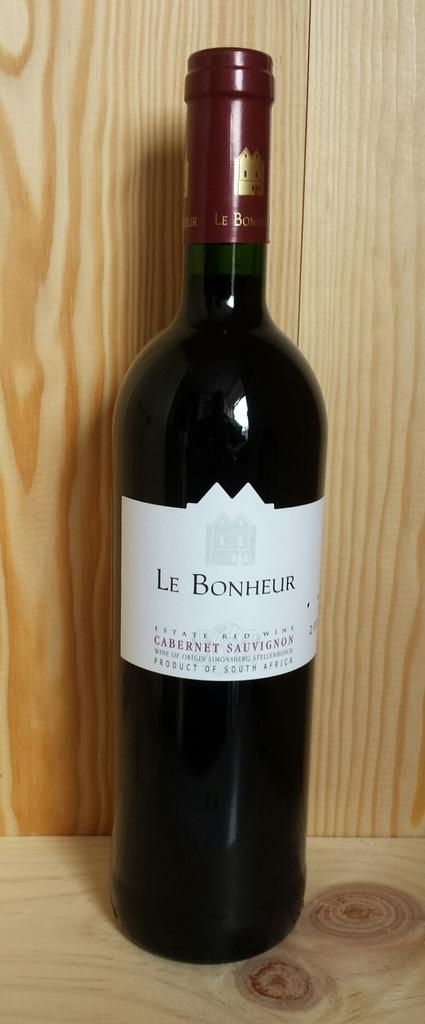Provide a one-sentence caption for the provided image. A bottle of Le Bonheur wine is in front of a wooden background. 